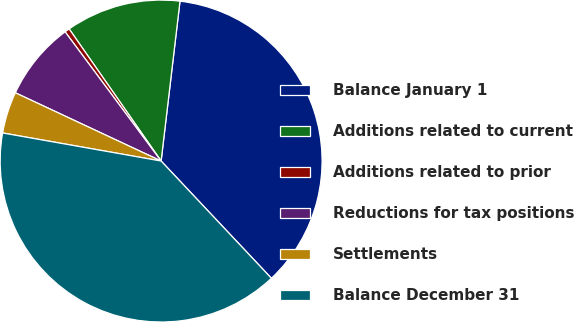Convert chart. <chart><loc_0><loc_0><loc_500><loc_500><pie_chart><fcel>Balance January 1<fcel>Additions related to current<fcel>Additions related to prior<fcel>Reductions for tax positions<fcel>Settlements<fcel>Balance December 31<nl><fcel>36.11%<fcel>11.55%<fcel>0.49%<fcel>7.86%<fcel>4.18%<fcel>39.8%<nl></chart> 